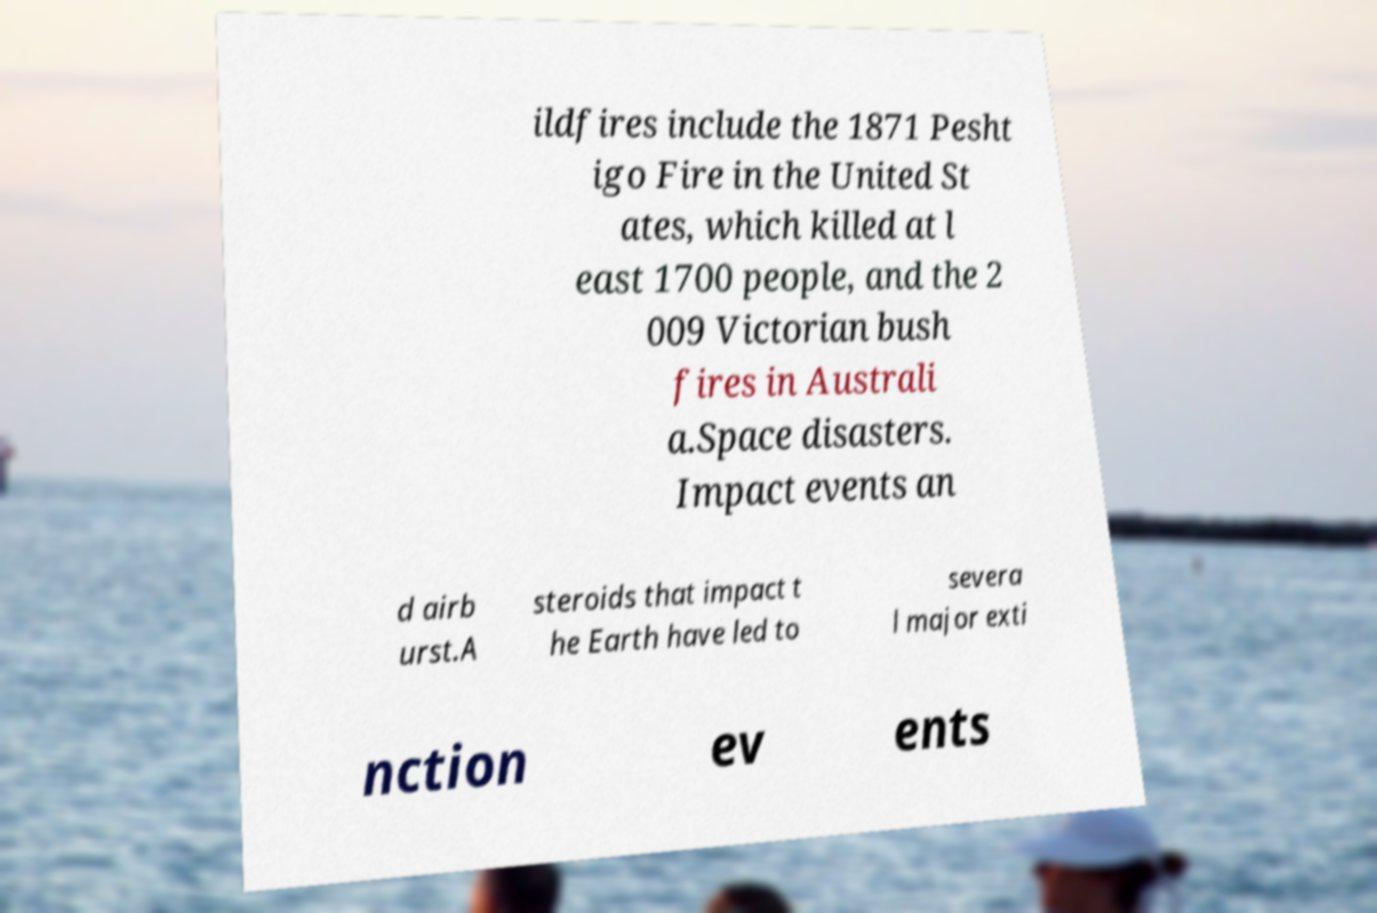Could you assist in decoding the text presented in this image and type it out clearly? ildfires include the 1871 Pesht igo Fire in the United St ates, which killed at l east 1700 people, and the 2 009 Victorian bush fires in Australi a.Space disasters. Impact events an d airb urst.A steroids that impact t he Earth have led to severa l major exti nction ev ents 